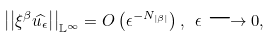Convert formula to latex. <formula><loc_0><loc_0><loc_500><loc_500>\left | \left | \xi ^ { \beta } \widehat { u _ { \epsilon } } \right | \right | _ { \mathbb { L } ^ { \infty } } = O \left ( \epsilon ^ { - N _ { \left | \beta \right | } } \right ) , \text { } \epsilon \longrightarrow 0 ,</formula> 